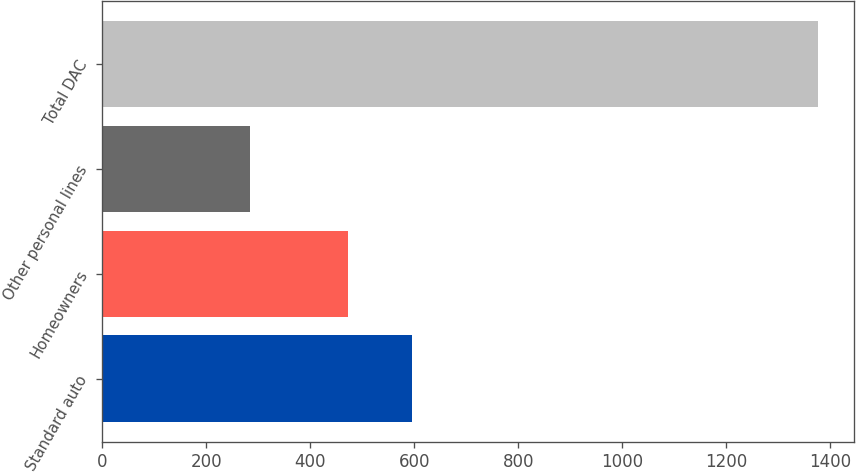Convert chart to OTSL. <chart><loc_0><loc_0><loc_500><loc_500><bar_chart><fcel>Standard auto<fcel>Homeowners<fcel>Other personal lines<fcel>Total DAC<nl><fcel>596<fcel>473<fcel>283<fcel>1377<nl></chart> 